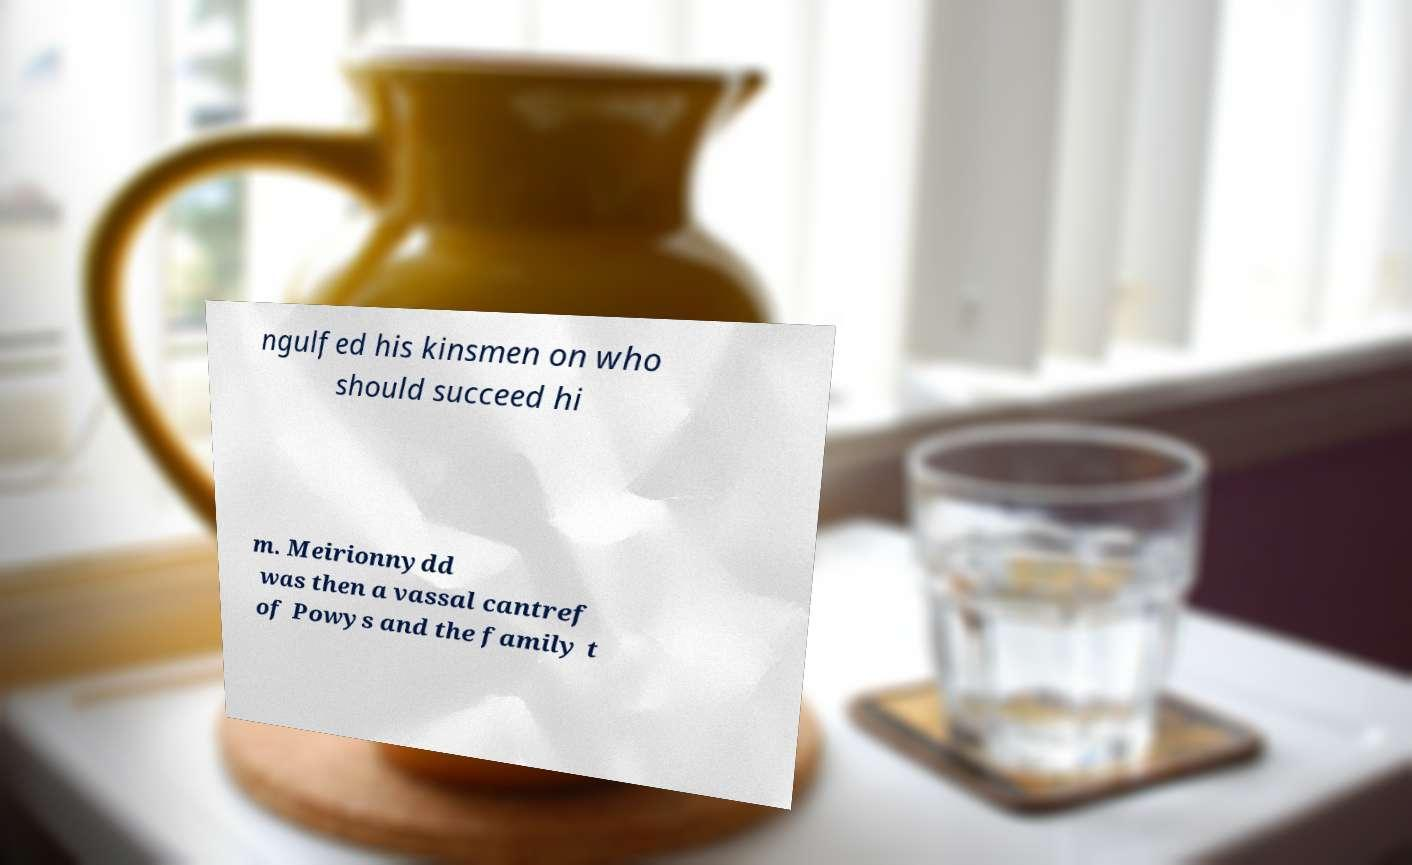For documentation purposes, I need the text within this image transcribed. Could you provide that? ngulfed his kinsmen on who should succeed hi m. Meirionnydd was then a vassal cantref of Powys and the family t 